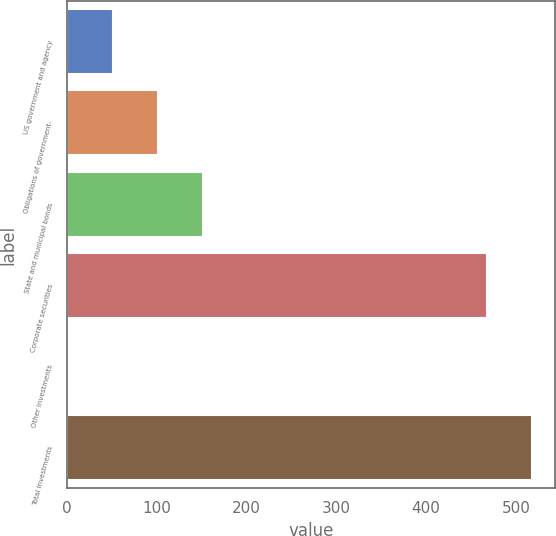Convert chart. <chart><loc_0><loc_0><loc_500><loc_500><bar_chart><fcel>US government and agency<fcel>Obligations of government-<fcel>State and municipal bonds<fcel>Corporate securities<fcel>Other investments<fcel>Total investments<nl><fcel>51.65<fcel>101.36<fcel>151.07<fcel>468<fcel>1.94<fcel>517.71<nl></chart> 